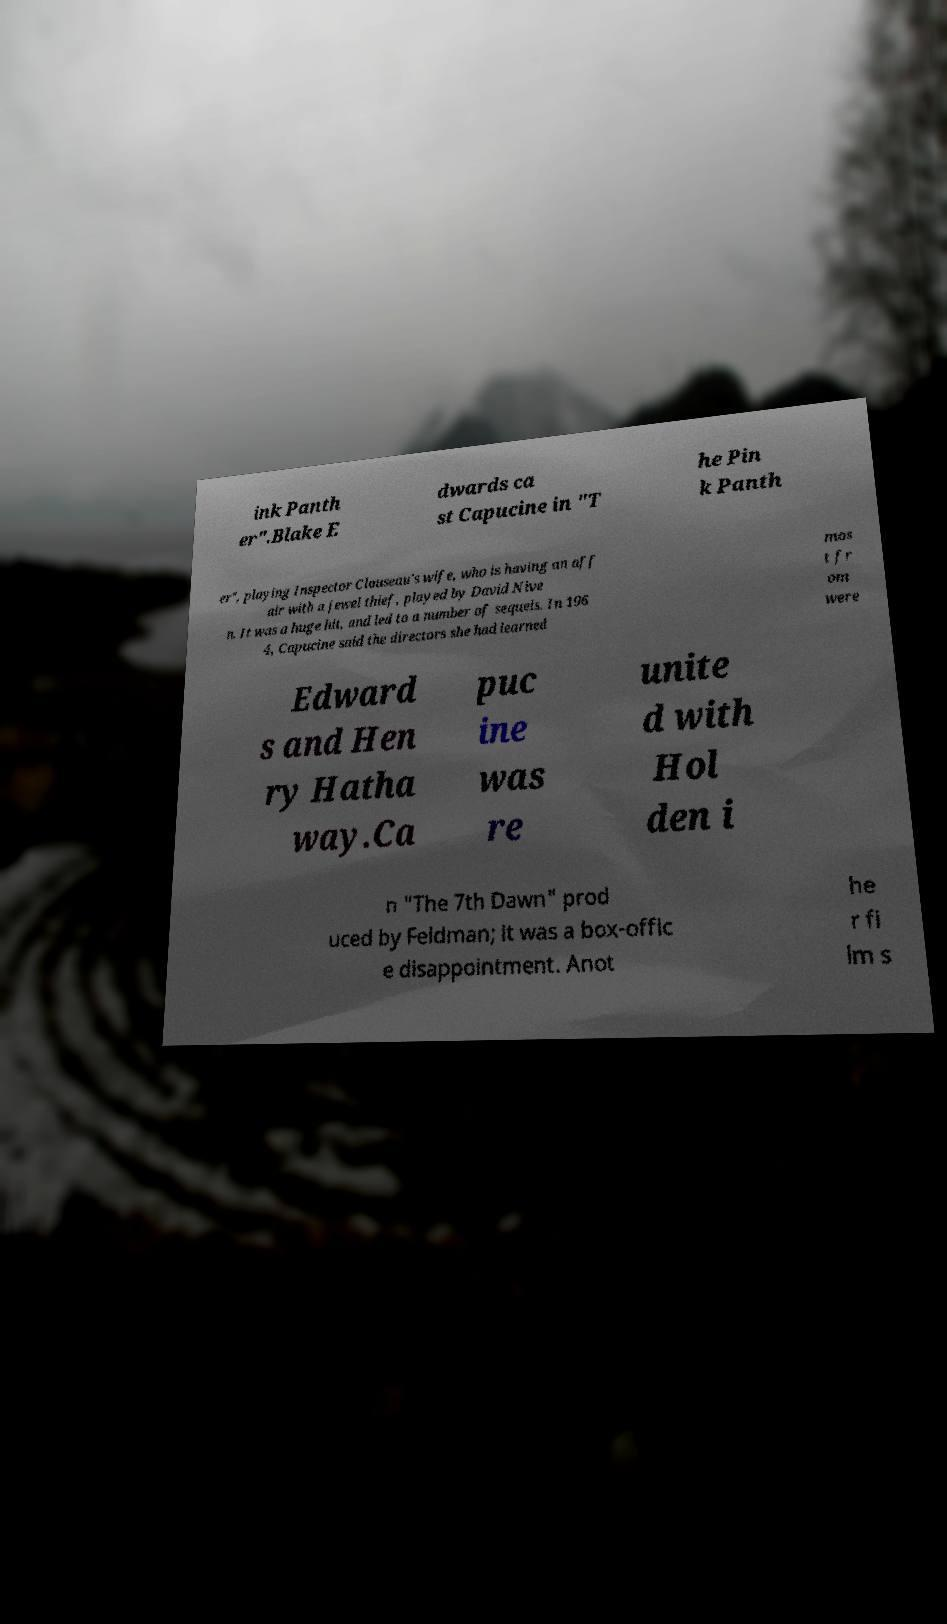I need the written content from this picture converted into text. Can you do that? ink Panth er".Blake E dwards ca st Capucine in "T he Pin k Panth er", playing Inspector Clouseau's wife, who is having an aff air with a jewel thief, played by David Nive n. It was a huge hit, and led to a number of sequels. In 196 4, Capucine said the directors she had learned mos t fr om were Edward s and Hen ry Hatha way.Ca puc ine was re unite d with Hol den i n "The 7th Dawn" prod uced by Feldman; it was a box-offic e disappointment. Anot he r fi lm s 